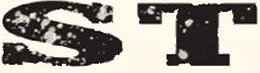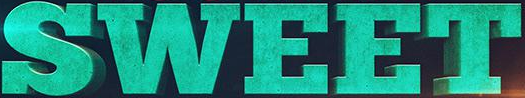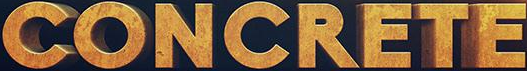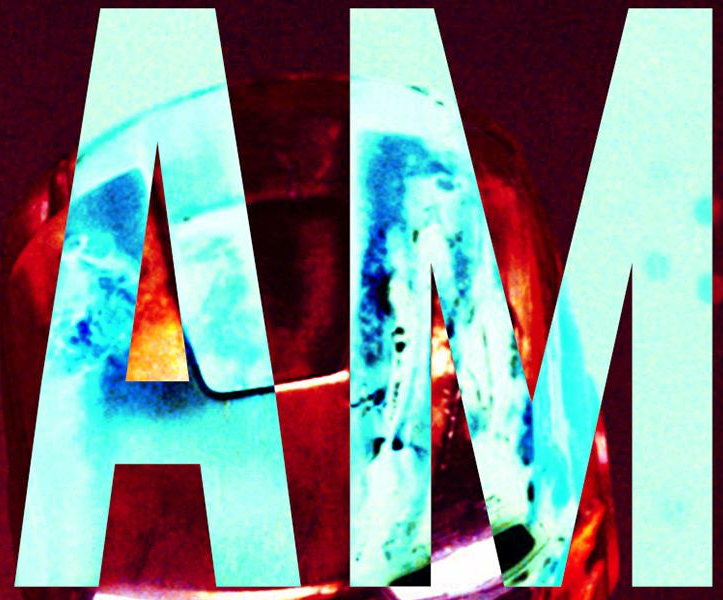Read the text content from these images in order, separated by a semicolon. ST; SWEET; CONCRETE; AM 